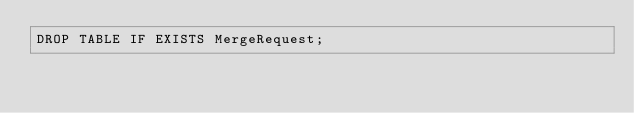Convert code to text. <code><loc_0><loc_0><loc_500><loc_500><_SQL_>DROP TABLE IF EXISTS MergeRequest;</code> 